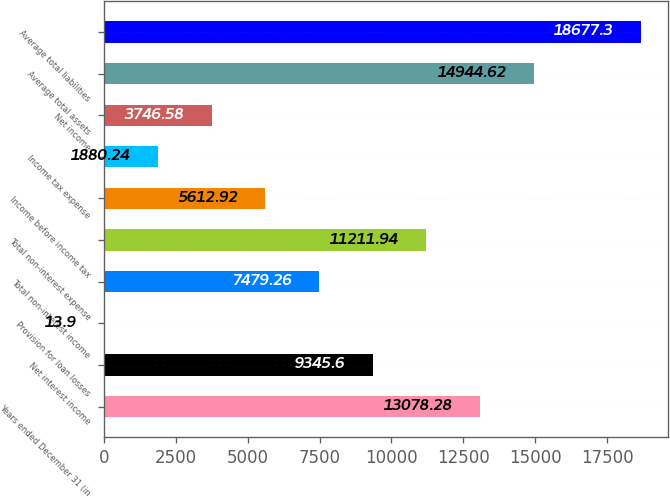Convert chart. <chart><loc_0><loc_0><loc_500><loc_500><bar_chart><fcel>Years ended December 31 (in<fcel>Net interest income<fcel>Provision for loan losses<fcel>Total non-interest income<fcel>Total non-interest expense<fcel>Income before income tax<fcel>Income tax expense<fcel>Net income<fcel>Average total assets<fcel>Average total liabilities<nl><fcel>13078.3<fcel>9345.6<fcel>13.9<fcel>7479.26<fcel>11211.9<fcel>5612.92<fcel>1880.24<fcel>3746.58<fcel>14944.6<fcel>18677.3<nl></chart> 